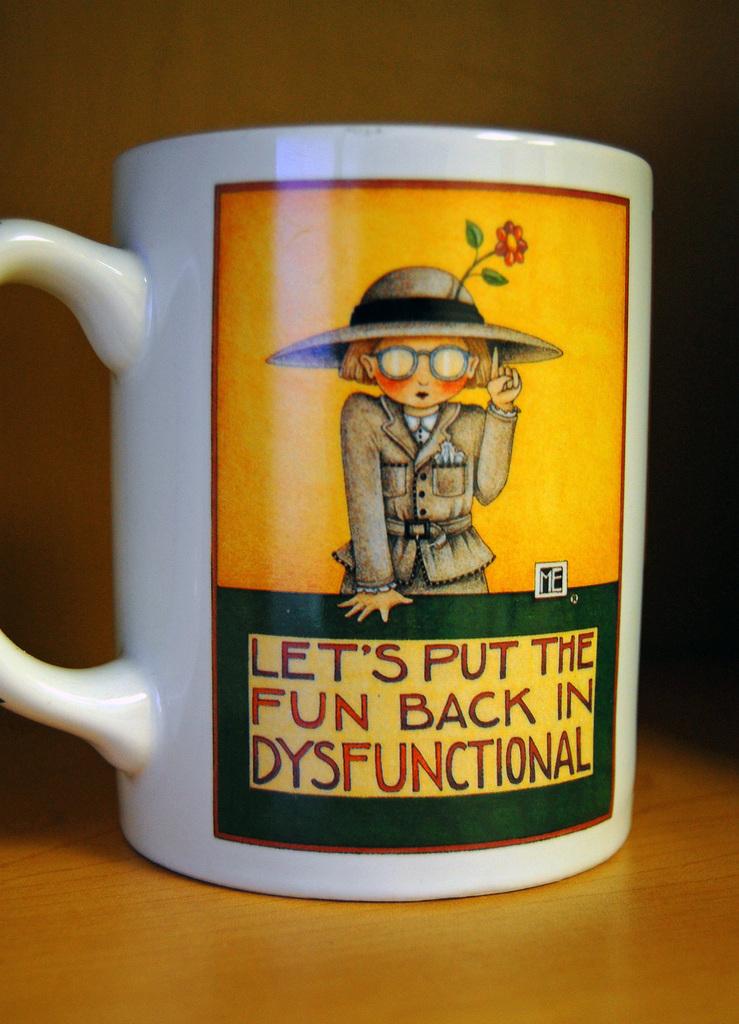What word are you putting back into dysfunctional?
Make the answer very short. Fun. What are they putting fun back in?
Provide a short and direct response. Dysfunctional. 